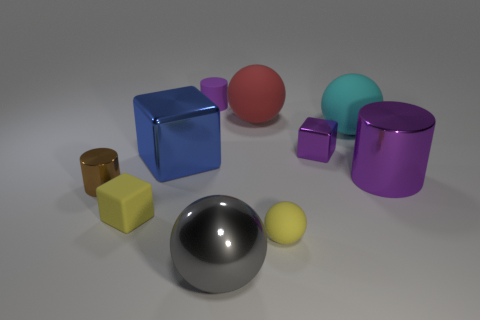Is the number of large gray metal spheres greater than the number of large matte things? No, the number of large gray metal spheres is not greater; there is one large gray metal sphere and there are also several large objects with a matte finish in the image. 